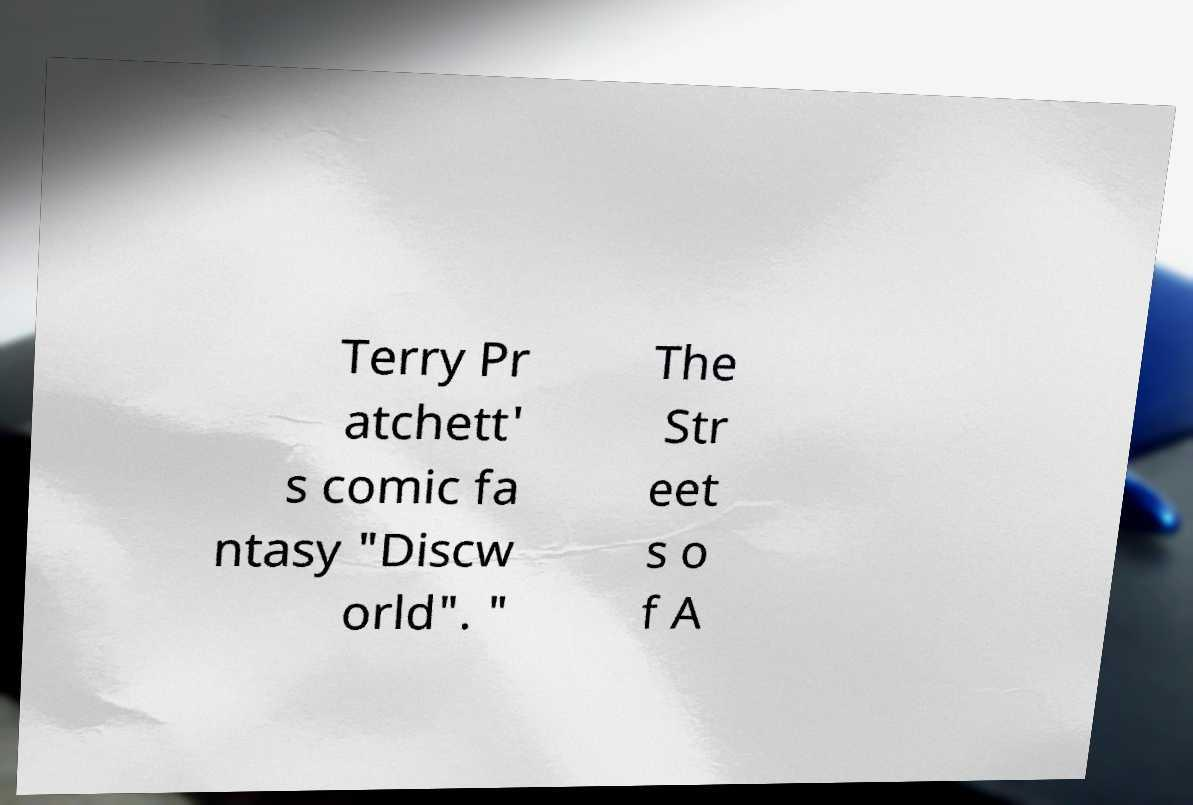Please identify and transcribe the text found in this image. Terry Pr atchett' s comic fa ntasy "Discw orld". " The Str eet s o f A 